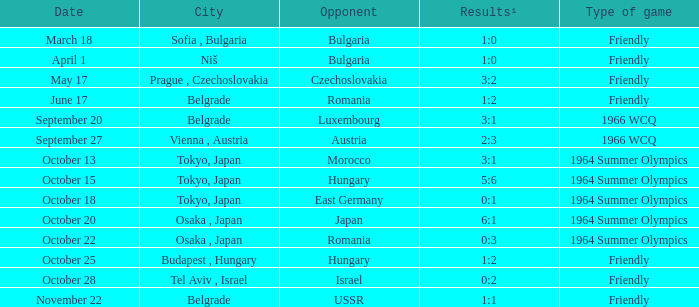Which city experienced a happening on the 13th of october? Tokyo, Japan. 